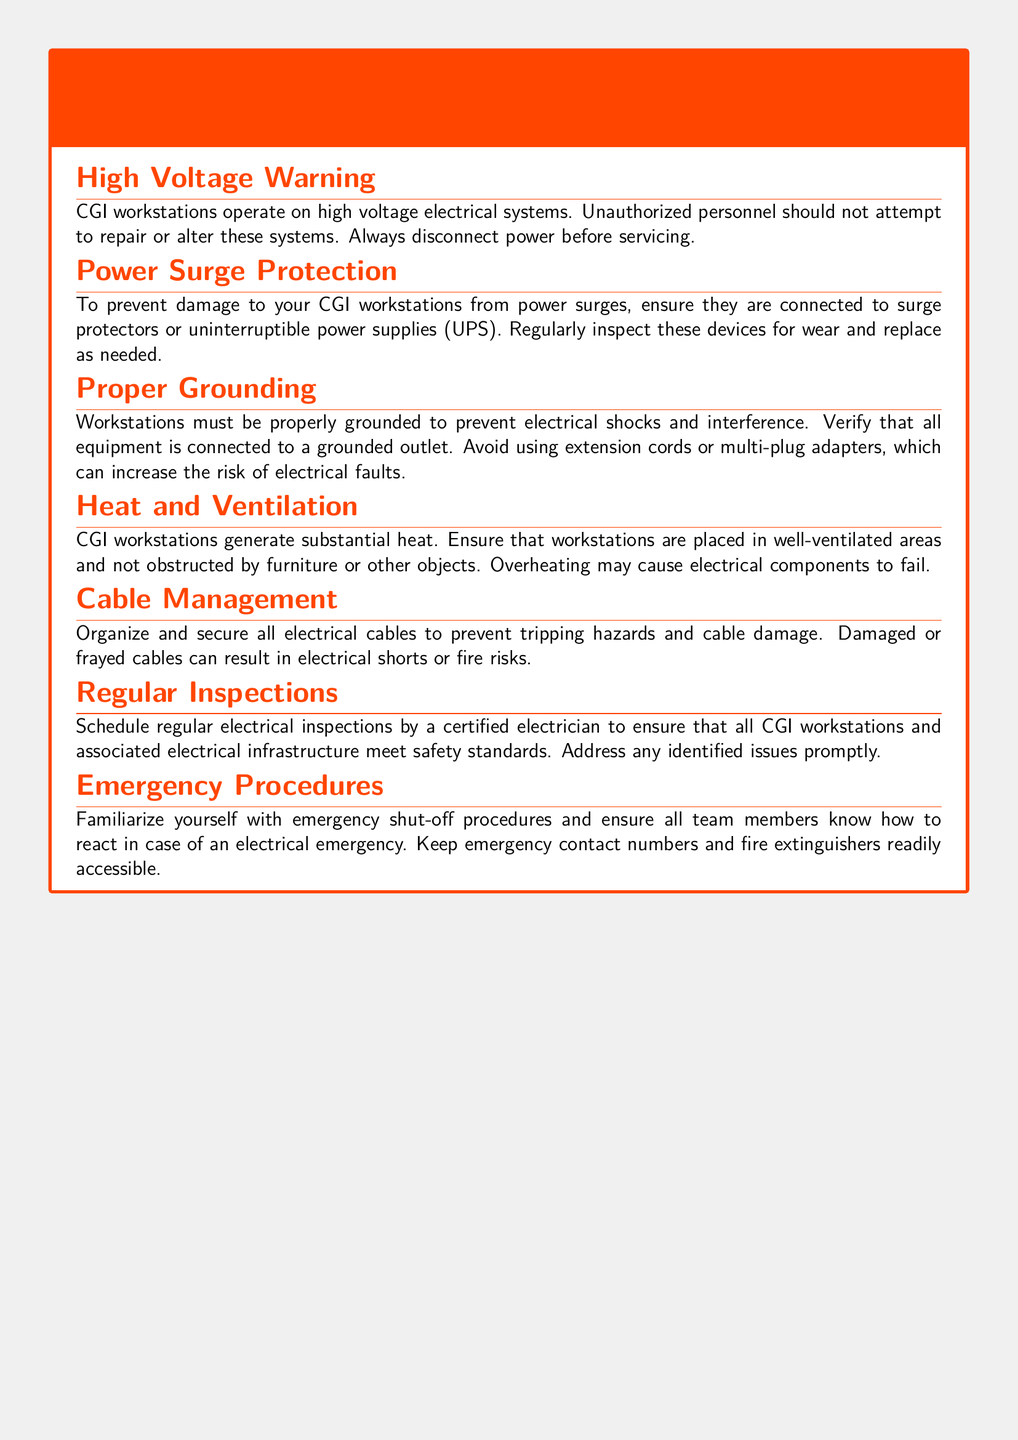what should you do before servicing CGI workstations? The document advises to always disconnect power before servicing.
Answer: disconnect power what is the recommended device to protect against power surges? The text mentions that surge protectors or uninterruptible power supplies (UPS) should be used.
Answer: surge protectors or uninterruptible power supplies (UPS) how should workstations be connected to prevent electrical shocks? It specifies that workstations must be properly grounded to prevent shocks.
Answer: properly grounded what is a consequence of overheating CGI workstations? The document states that overheating may cause electrical components to fail.
Answer: electrical components to fail how often should electrical inspections be conducted? The document recommends scheduling regular inspections by a certified electrician.
Answer: regularly which items should be readily accessible in case of an electrical emergency? Emergency contact numbers and fire extinguishers should be accessible.
Answer: emergency contact numbers and fire extinguishers what risk is associated with damaged or frayed cables? The document indicates that damaged cables can result in electrical shorts or fire risks.
Answer: electrical shorts or fire risks why is it not recommended to use extension cords? The text indicates that using extension cords can increase the risk of electrical faults.
Answer: increase the risk of electrical faults what is the primary focus of this document? This document provides warnings and safety notices for CGI workstations.
Answer: warnings and safety notices for CGI workstations 